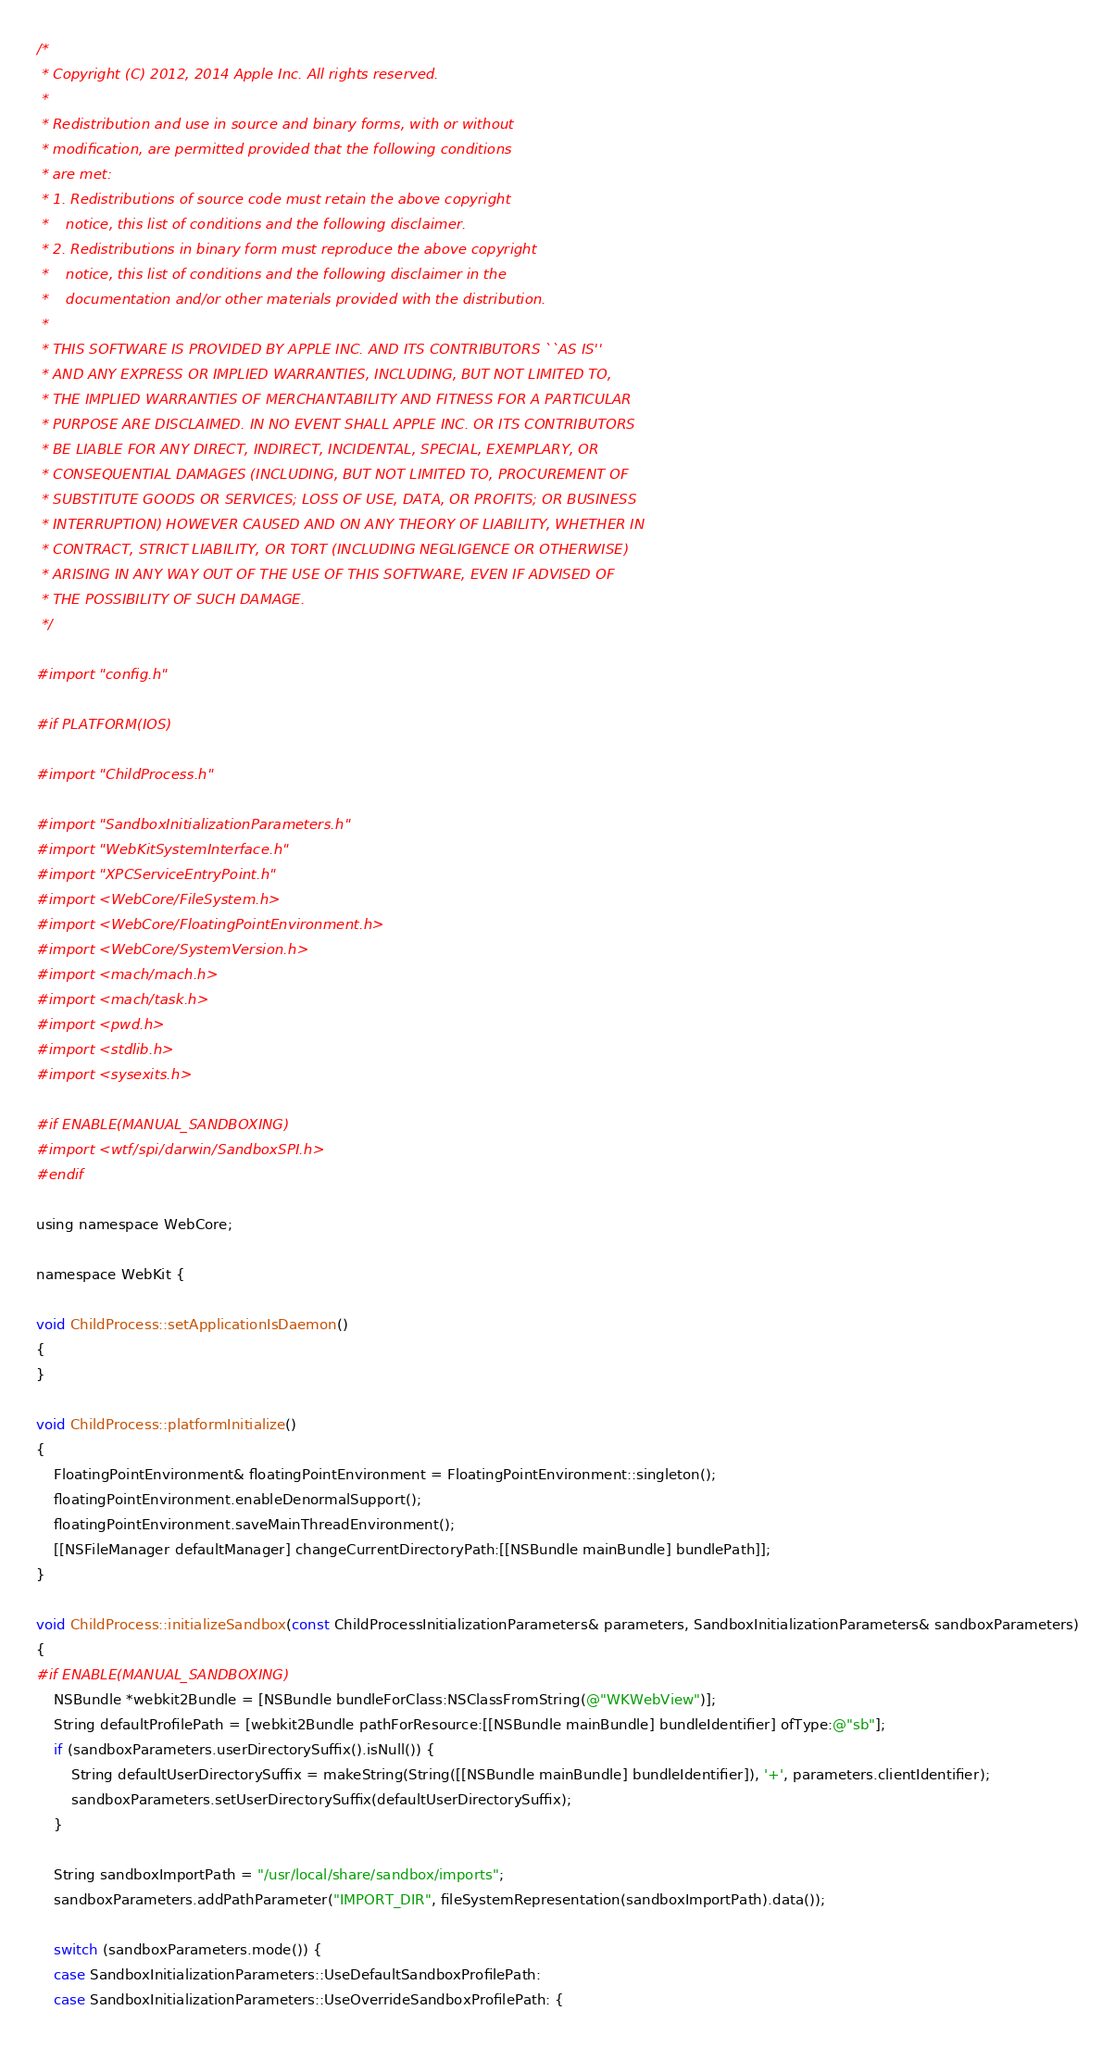<code> <loc_0><loc_0><loc_500><loc_500><_ObjectiveC_>/*
 * Copyright (C) 2012, 2014 Apple Inc. All rights reserved.
 *
 * Redistribution and use in source and binary forms, with or without
 * modification, are permitted provided that the following conditions
 * are met:
 * 1. Redistributions of source code must retain the above copyright
 *    notice, this list of conditions and the following disclaimer.
 * 2. Redistributions in binary form must reproduce the above copyright
 *    notice, this list of conditions and the following disclaimer in the
 *    documentation and/or other materials provided with the distribution.
 *
 * THIS SOFTWARE IS PROVIDED BY APPLE INC. AND ITS CONTRIBUTORS ``AS IS''
 * AND ANY EXPRESS OR IMPLIED WARRANTIES, INCLUDING, BUT NOT LIMITED TO,
 * THE IMPLIED WARRANTIES OF MERCHANTABILITY AND FITNESS FOR A PARTICULAR
 * PURPOSE ARE DISCLAIMED. IN NO EVENT SHALL APPLE INC. OR ITS CONTRIBUTORS
 * BE LIABLE FOR ANY DIRECT, INDIRECT, INCIDENTAL, SPECIAL, EXEMPLARY, OR
 * CONSEQUENTIAL DAMAGES (INCLUDING, BUT NOT LIMITED TO, PROCUREMENT OF
 * SUBSTITUTE GOODS OR SERVICES; LOSS OF USE, DATA, OR PROFITS; OR BUSINESS
 * INTERRUPTION) HOWEVER CAUSED AND ON ANY THEORY OF LIABILITY, WHETHER IN
 * CONTRACT, STRICT LIABILITY, OR TORT (INCLUDING NEGLIGENCE OR OTHERWISE)
 * ARISING IN ANY WAY OUT OF THE USE OF THIS SOFTWARE, EVEN IF ADVISED OF
 * THE POSSIBILITY OF SUCH DAMAGE.
 */

#import "config.h"

#if PLATFORM(IOS)

#import "ChildProcess.h"

#import "SandboxInitializationParameters.h"
#import "WebKitSystemInterface.h"
#import "XPCServiceEntryPoint.h"
#import <WebCore/FileSystem.h>
#import <WebCore/FloatingPointEnvironment.h>
#import <WebCore/SystemVersion.h>
#import <mach/mach.h>
#import <mach/task.h>
#import <pwd.h>
#import <stdlib.h>
#import <sysexits.h>

#if ENABLE(MANUAL_SANDBOXING)
#import <wtf/spi/darwin/SandboxSPI.h>
#endif

using namespace WebCore;

namespace WebKit {

void ChildProcess::setApplicationIsDaemon()
{
}

void ChildProcess::platformInitialize()
{
    FloatingPointEnvironment& floatingPointEnvironment = FloatingPointEnvironment::singleton(); 
    floatingPointEnvironment.enableDenormalSupport(); 
    floatingPointEnvironment.saveMainThreadEnvironment(); 
    [[NSFileManager defaultManager] changeCurrentDirectoryPath:[[NSBundle mainBundle] bundlePath]];
}

void ChildProcess::initializeSandbox(const ChildProcessInitializationParameters& parameters, SandboxInitializationParameters& sandboxParameters)
{
#if ENABLE(MANUAL_SANDBOXING)
    NSBundle *webkit2Bundle = [NSBundle bundleForClass:NSClassFromString(@"WKWebView")];
    String defaultProfilePath = [webkit2Bundle pathForResource:[[NSBundle mainBundle] bundleIdentifier] ofType:@"sb"];
    if (sandboxParameters.userDirectorySuffix().isNull()) {
        String defaultUserDirectorySuffix = makeString(String([[NSBundle mainBundle] bundleIdentifier]), '+', parameters.clientIdentifier);
        sandboxParameters.setUserDirectorySuffix(defaultUserDirectorySuffix);
    }

    String sandboxImportPath = "/usr/local/share/sandbox/imports";
    sandboxParameters.addPathParameter("IMPORT_DIR", fileSystemRepresentation(sandboxImportPath).data());

    switch (sandboxParameters.mode()) {
    case SandboxInitializationParameters::UseDefaultSandboxProfilePath:
    case SandboxInitializationParameters::UseOverrideSandboxProfilePath: {</code> 